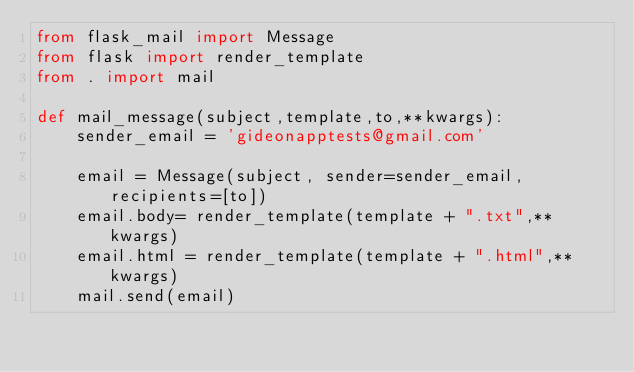<code> <loc_0><loc_0><loc_500><loc_500><_Python_>from flask_mail import Message
from flask import render_template
from . import mail

def mail_message(subject,template,to,**kwargs):
    sender_email = 'gideonapptests@gmail.com'

    email = Message(subject, sender=sender_email, recipients=[to])
    email.body= render_template(template + ".txt",**kwargs)
    email.html = render_template(template + ".html",**kwargs)
    mail.send(email)</code> 